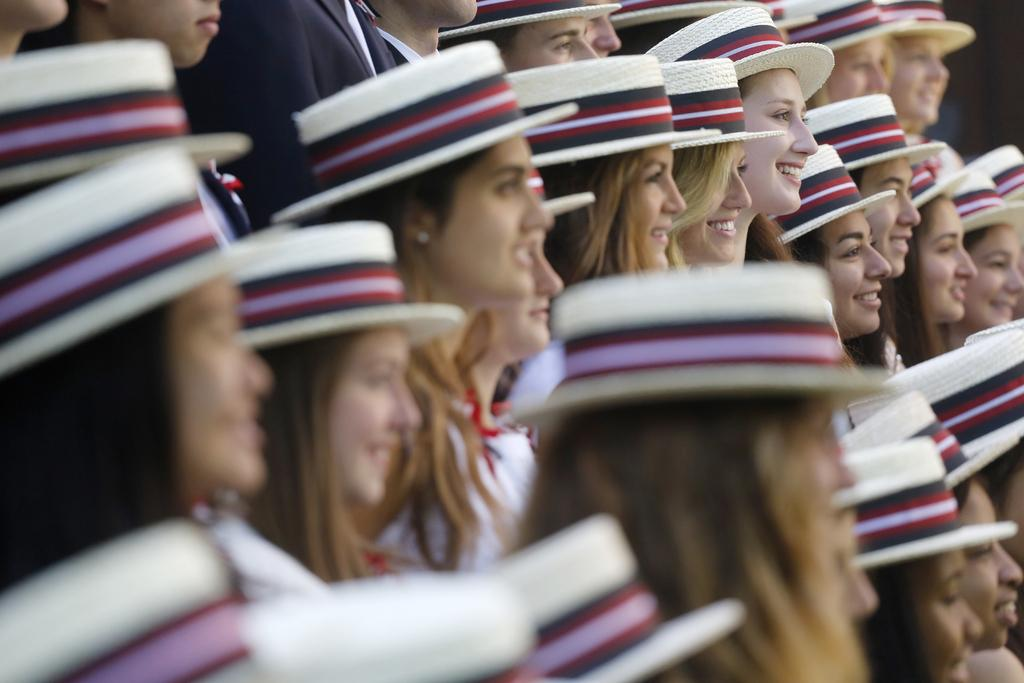How many women are in the image? There are multiple women in the image. What do the women have in common in terms of their appearance? The women are wearing hats of the same color. How are the hats positioned on their heads? The hats are worn over their heads. What is the facial expression of the women in the image? The women are smiling. What type of selection is being made by the women in the image? There is no indication in the image that the women are making a selection. --- Facts: 1. There is a car in the image. 2. The car is parked on the street. 3. The car is red. 4. There are trees in the background. Absurd Topics: dance, ocean, instrument Conversation: What is the main subject of the image? The main subject of the image is a car. Where is the car located in the image? The car is parked on the street. What color is the car? The car is red. What can be seen in the background of the image? There are trees in the background. Reasoning: Let's think step by step in order to produce the conversation. We start by identifying the main subject in the image, which is the car. Then, we expand the conversation to include details about the car's location and color. Finally, we mention the background to provide a more complete description of the scene. Absurd Question/Answer: What type of dance is being performed by the car in the image? There is no indication in the image that the car is performing a dance. --- Facts: 1. There is a dog in the image. 2. The dog is sitting on a chair. 3. The chair is made of wood. 4. The dog is wearing a collar. Absurd Topics: painting, mountain, costume Conversation: What is the main subject of the image? The main subject of the image is a dog. Where is the dog located in the image? The dog is sitting on a chair. What is the chair made of? The chair is made of wood. What is the dog wearing in the image? The dog is wearing a collar. Reasoning: Let's think step by step in order to produce the conversation. We start by identifying the main subject in the image, which is the dog. Then, we expand the conversation to include details about the dog's location and the chair it is sitting on. Finally, we mention the dog's collar to provide a more complete description of the scene. Absurd Question/Answer: What type of painting is being created by the dog in the image? There is no indication in the image that the dog is creating a painting. 